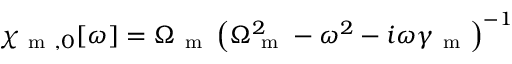Convert formula to latex. <formula><loc_0><loc_0><loc_500><loc_500>\chi _ { m , 0 } [ \omega ] = \Omega _ { m } \left ( \Omega _ { m } ^ { 2 } - \omega ^ { 2 } - i \omega \gamma _ { m } \right ) ^ { - 1 }</formula> 